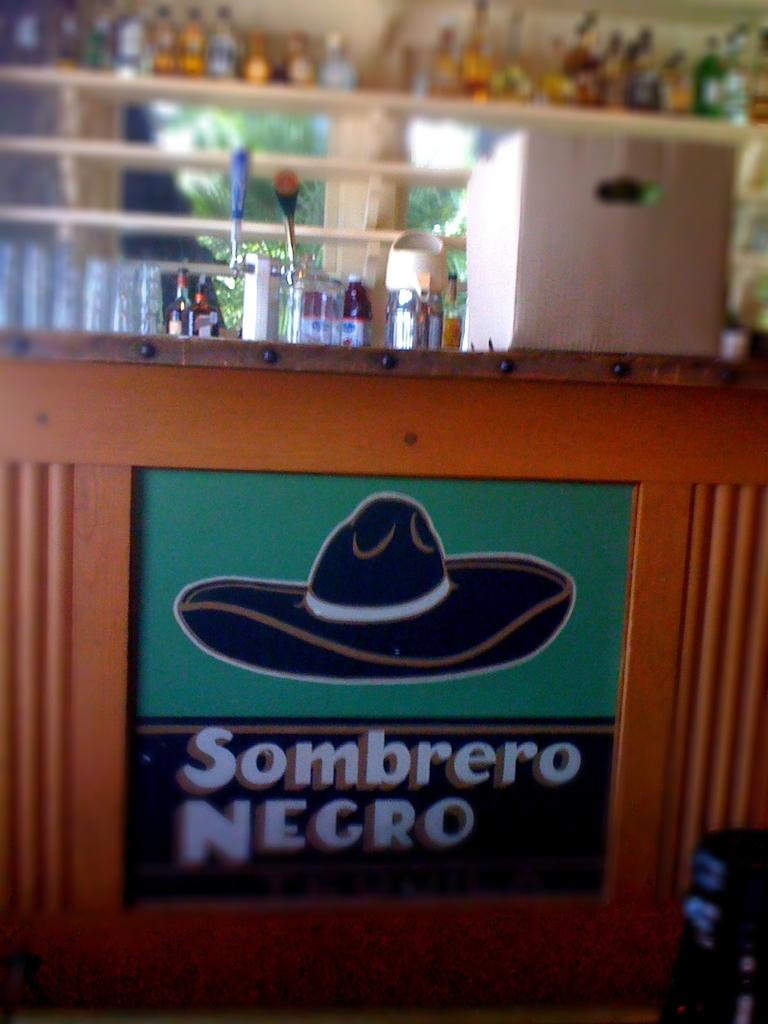<image>
Describe the image concisely. a bar area that has the words sombrero negro on them 